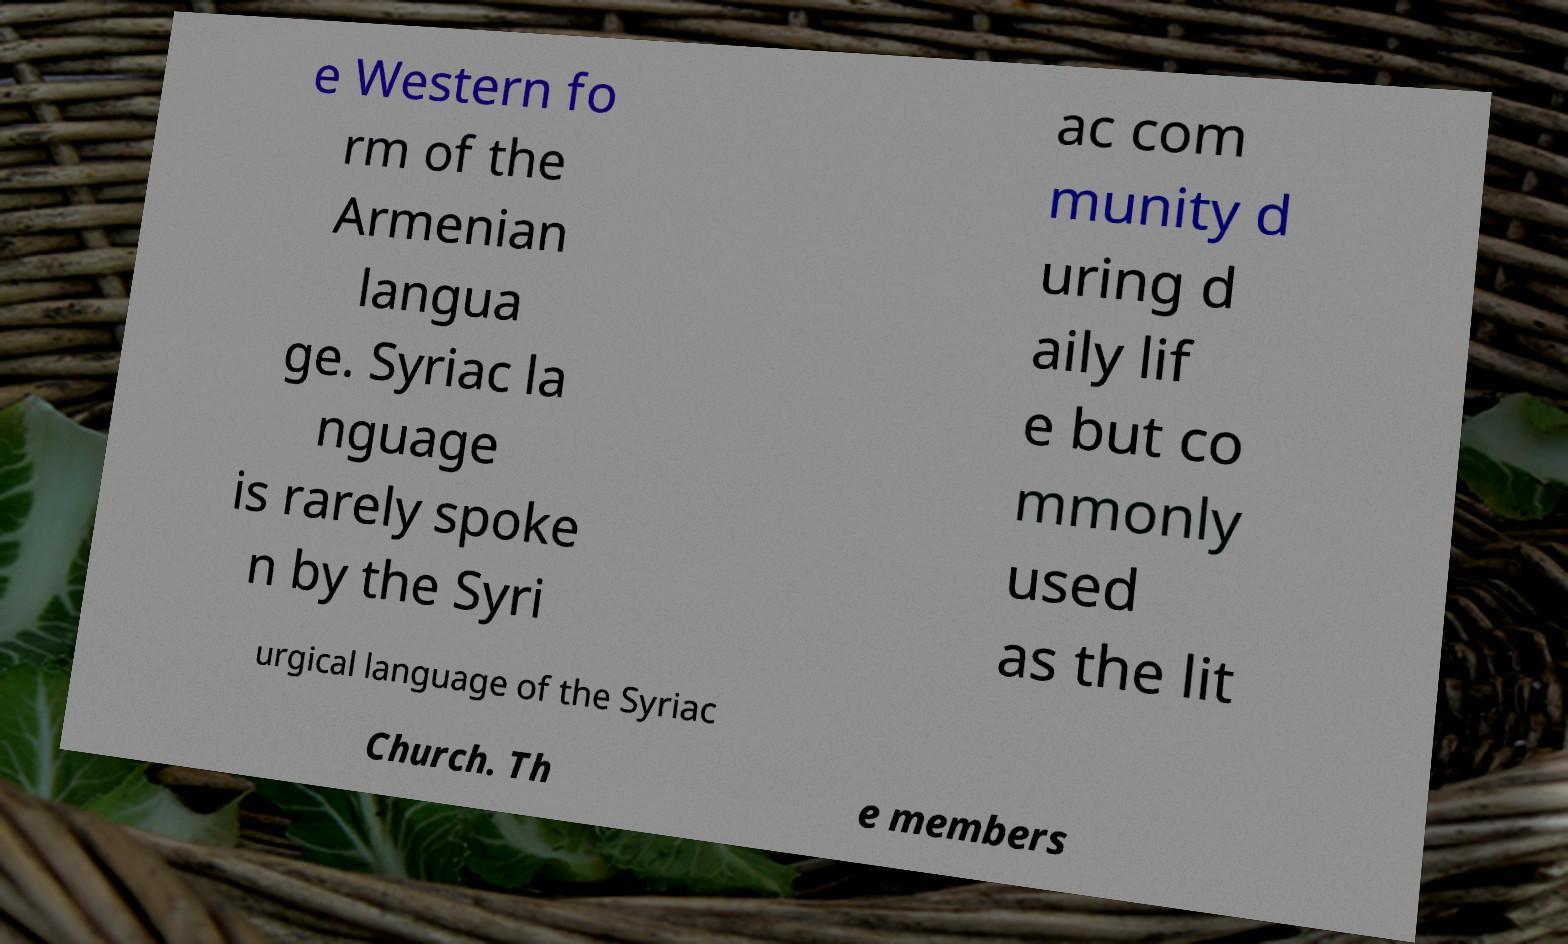Could you extract and type out the text from this image? e Western fo rm of the Armenian langua ge. Syriac la nguage is rarely spoke n by the Syri ac com munity d uring d aily lif e but co mmonly used as the lit urgical language of the Syriac Church. Th e members 